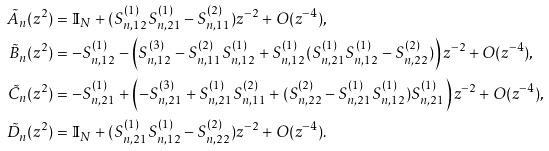Convert formula to latex. <formula><loc_0><loc_0><loc_500><loc_500>\tilde { A } _ { n } ( z ^ { 2 } ) & = { \mathbb { I } } _ { N } + ( S ^ { ( 1 ) } _ { n , 1 2 } S ^ { ( 1 ) } _ { n , 2 1 } - S ^ { ( 2 ) } _ { n , 1 1 } ) z ^ { - 2 } + O ( z ^ { - 4 } ) , \\ \tilde { B } _ { n } ( z ^ { 2 } ) & = - S ^ { ( 1 ) } _ { n , 1 2 } - \left ( S ^ { ( 3 ) } _ { n , 1 2 } - S ^ { ( 2 ) } _ { n , 1 1 } S ^ { ( 1 ) } _ { n , 1 2 } + S ^ { ( 1 ) } _ { n , 1 2 } ( S ^ { ( 1 ) } _ { n , 2 1 } S ^ { ( 1 ) } _ { n , 1 2 } - S ^ { ( 2 ) } _ { n , 2 2 } ) \right ) z ^ { - 2 } + O ( z ^ { - 4 } ) , \\ \tilde { C } _ { n } ( z ^ { 2 } ) & = - S ^ { ( 1 ) } _ { n , 2 1 } + \left ( - S ^ { ( 3 ) } _ { n , 2 1 } + S ^ { ( 1 ) } _ { n , 2 1 } S ^ { ( 2 ) } _ { n , 1 1 } + ( S ^ { ( 2 ) } _ { n , 2 2 } - S ^ { ( 1 ) } _ { n , 2 1 } S ^ { ( 1 ) } _ { n , 1 2 } ) S ^ { ( 1 ) } _ { n , 2 1 } \right ) z ^ { - 2 } + O ( z ^ { - 4 } ) , \\ \tilde { D } _ { n } ( z ^ { 2 } ) & = { \mathbb { I } } _ { N } + ( S ^ { ( 1 ) } _ { n , 2 1 } S ^ { ( 1 ) } _ { n , 1 2 } - S ^ { ( 2 ) } _ { n , 2 2 } ) z ^ { - 2 } + O ( z ^ { - 4 } ) .</formula> 